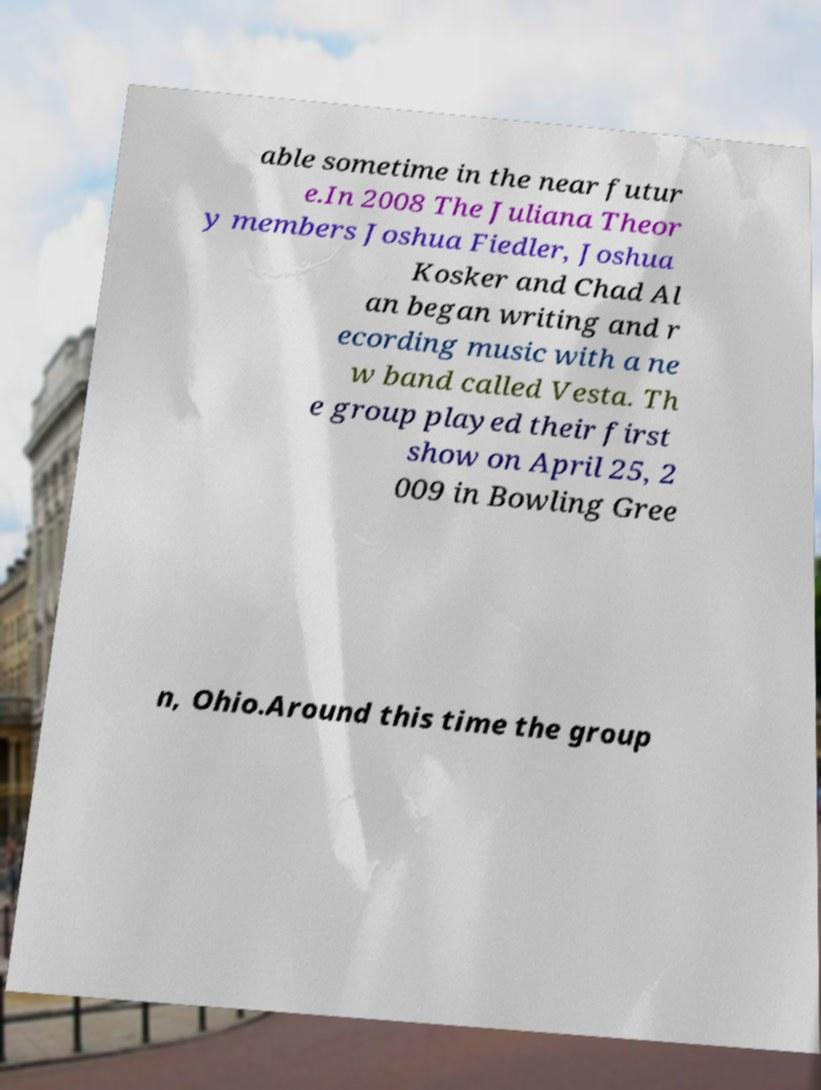Could you extract and type out the text from this image? able sometime in the near futur e.In 2008 The Juliana Theor y members Joshua Fiedler, Joshua Kosker and Chad Al an began writing and r ecording music with a ne w band called Vesta. Th e group played their first show on April 25, 2 009 in Bowling Gree n, Ohio.Around this time the group 